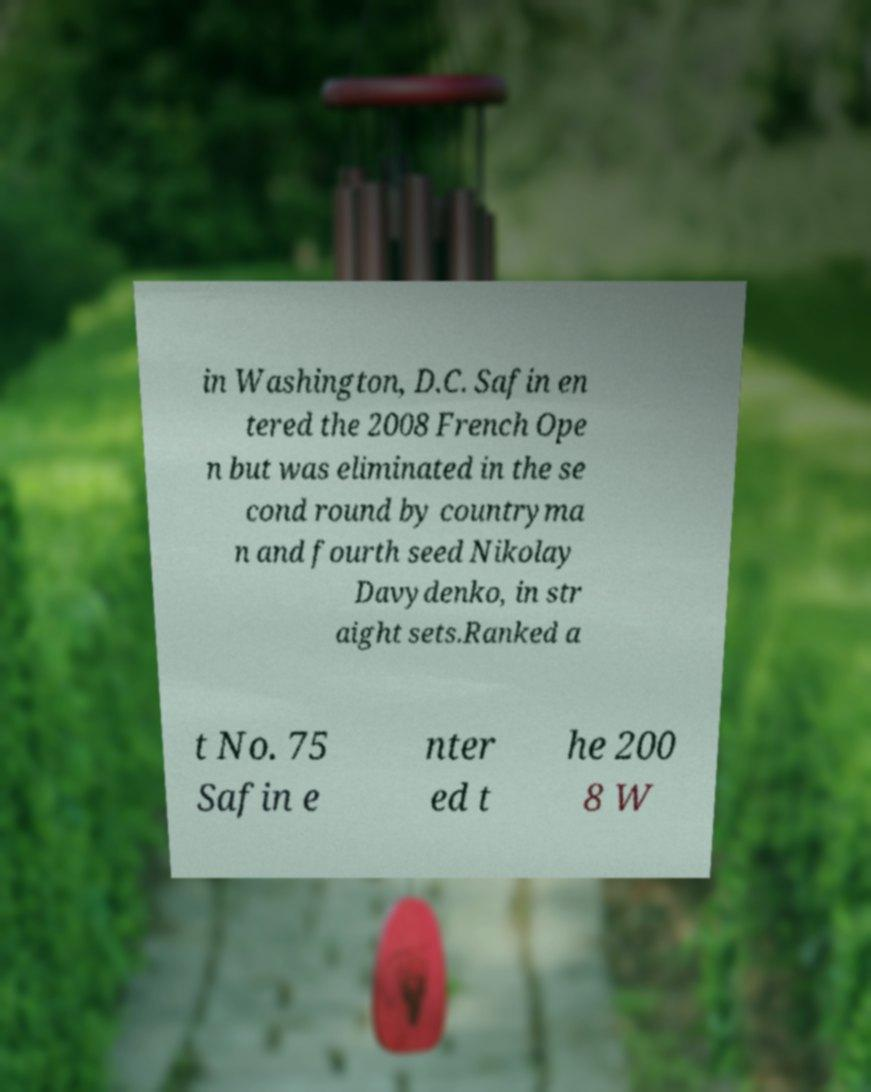What messages or text are displayed in this image? I need them in a readable, typed format. in Washington, D.C. Safin en tered the 2008 French Ope n but was eliminated in the se cond round by countryma n and fourth seed Nikolay Davydenko, in str aight sets.Ranked a t No. 75 Safin e nter ed t he 200 8 W 